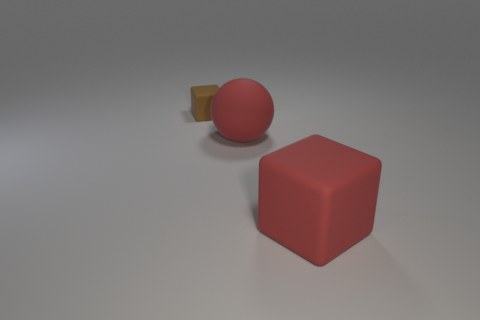If these objects were used in a game, what might the rules or objective be? If these objects were part of a game, a possible rule could involve spatial reasoning, like arranging them to fit within a designated area. The objective might be to position the shapes based on size or color constraints, testing the player's problem-solving abilities. 